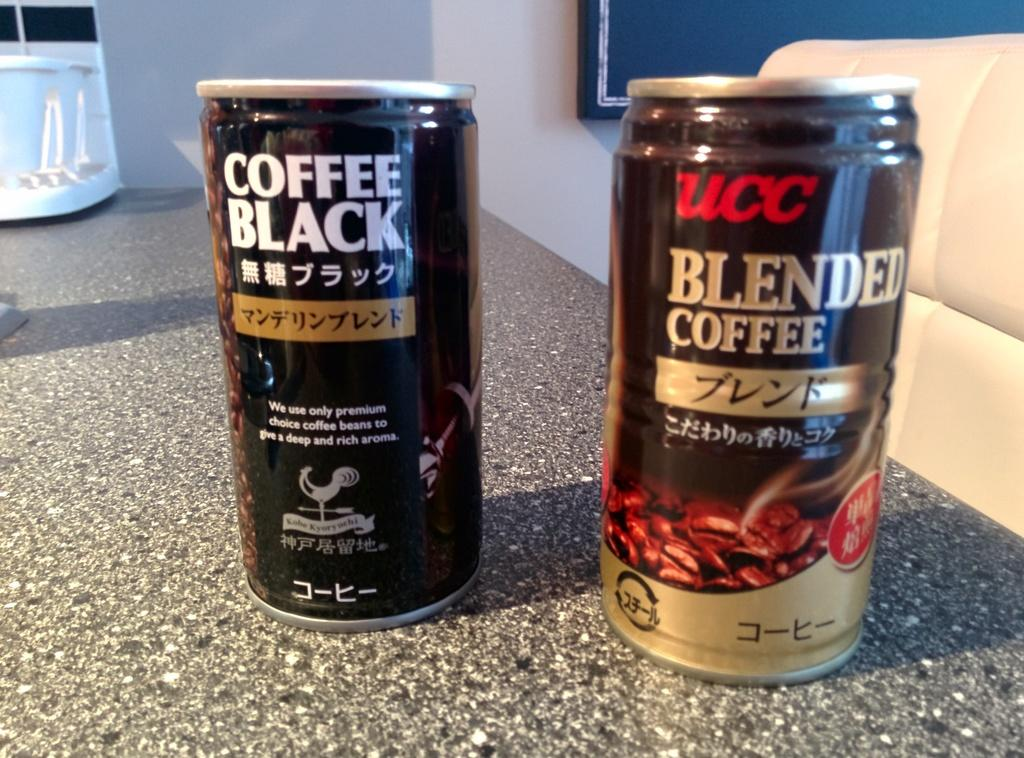Provide a one-sentence caption for the provided image. Can of Blended Coffee next to another black can. 